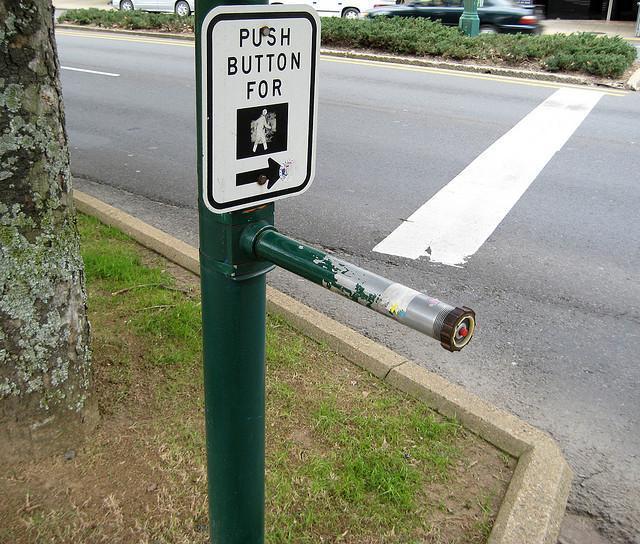How many chairs are empty?
Give a very brief answer. 0. 